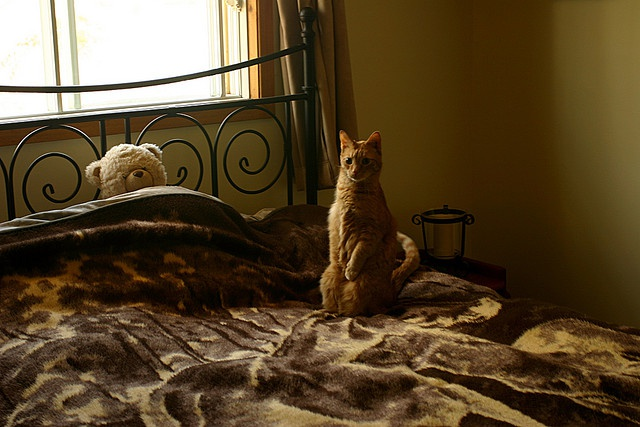Describe the objects in this image and their specific colors. I can see bed in white, black, maroon, and tan tones, cat in white, black, maroon, and olive tones, and teddy bear in white, olive, maroon, and tan tones in this image. 